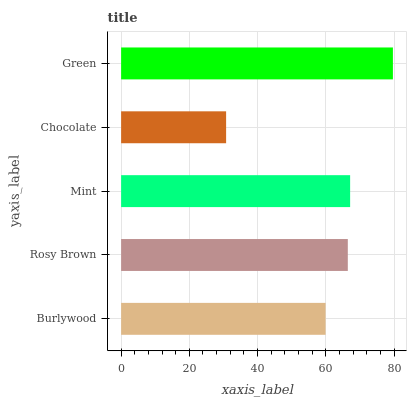Is Chocolate the minimum?
Answer yes or no. Yes. Is Green the maximum?
Answer yes or no. Yes. Is Rosy Brown the minimum?
Answer yes or no. No. Is Rosy Brown the maximum?
Answer yes or no. No. Is Rosy Brown greater than Burlywood?
Answer yes or no. Yes. Is Burlywood less than Rosy Brown?
Answer yes or no. Yes. Is Burlywood greater than Rosy Brown?
Answer yes or no. No. Is Rosy Brown less than Burlywood?
Answer yes or no. No. Is Rosy Brown the high median?
Answer yes or no. Yes. Is Rosy Brown the low median?
Answer yes or no. Yes. Is Green the high median?
Answer yes or no. No. Is Chocolate the low median?
Answer yes or no. No. 